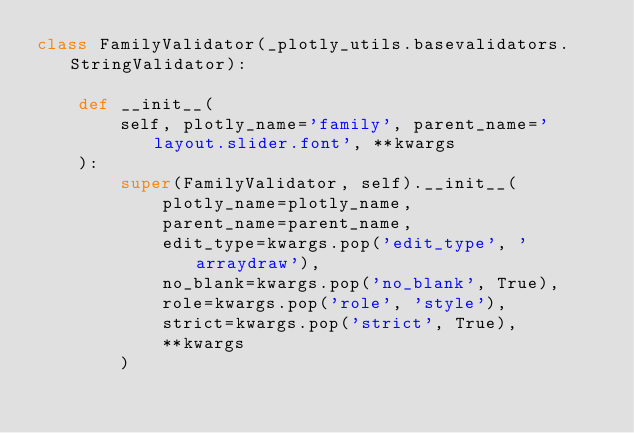<code> <loc_0><loc_0><loc_500><loc_500><_Python_>class FamilyValidator(_plotly_utils.basevalidators.StringValidator):

    def __init__(
        self, plotly_name='family', parent_name='layout.slider.font', **kwargs
    ):
        super(FamilyValidator, self).__init__(
            plotly_name=plotly_name,
            parent_name=parent_name,
            edit_type=kwargs.pop('edit_type', 'arraydraw'),
            no_blank=kwargs.pop('no_blank', True),
            role=kwargs.pop('role', 'style'),
            strict=kwargs.pop('strict', True),
            **kwargs
        )
</code> 